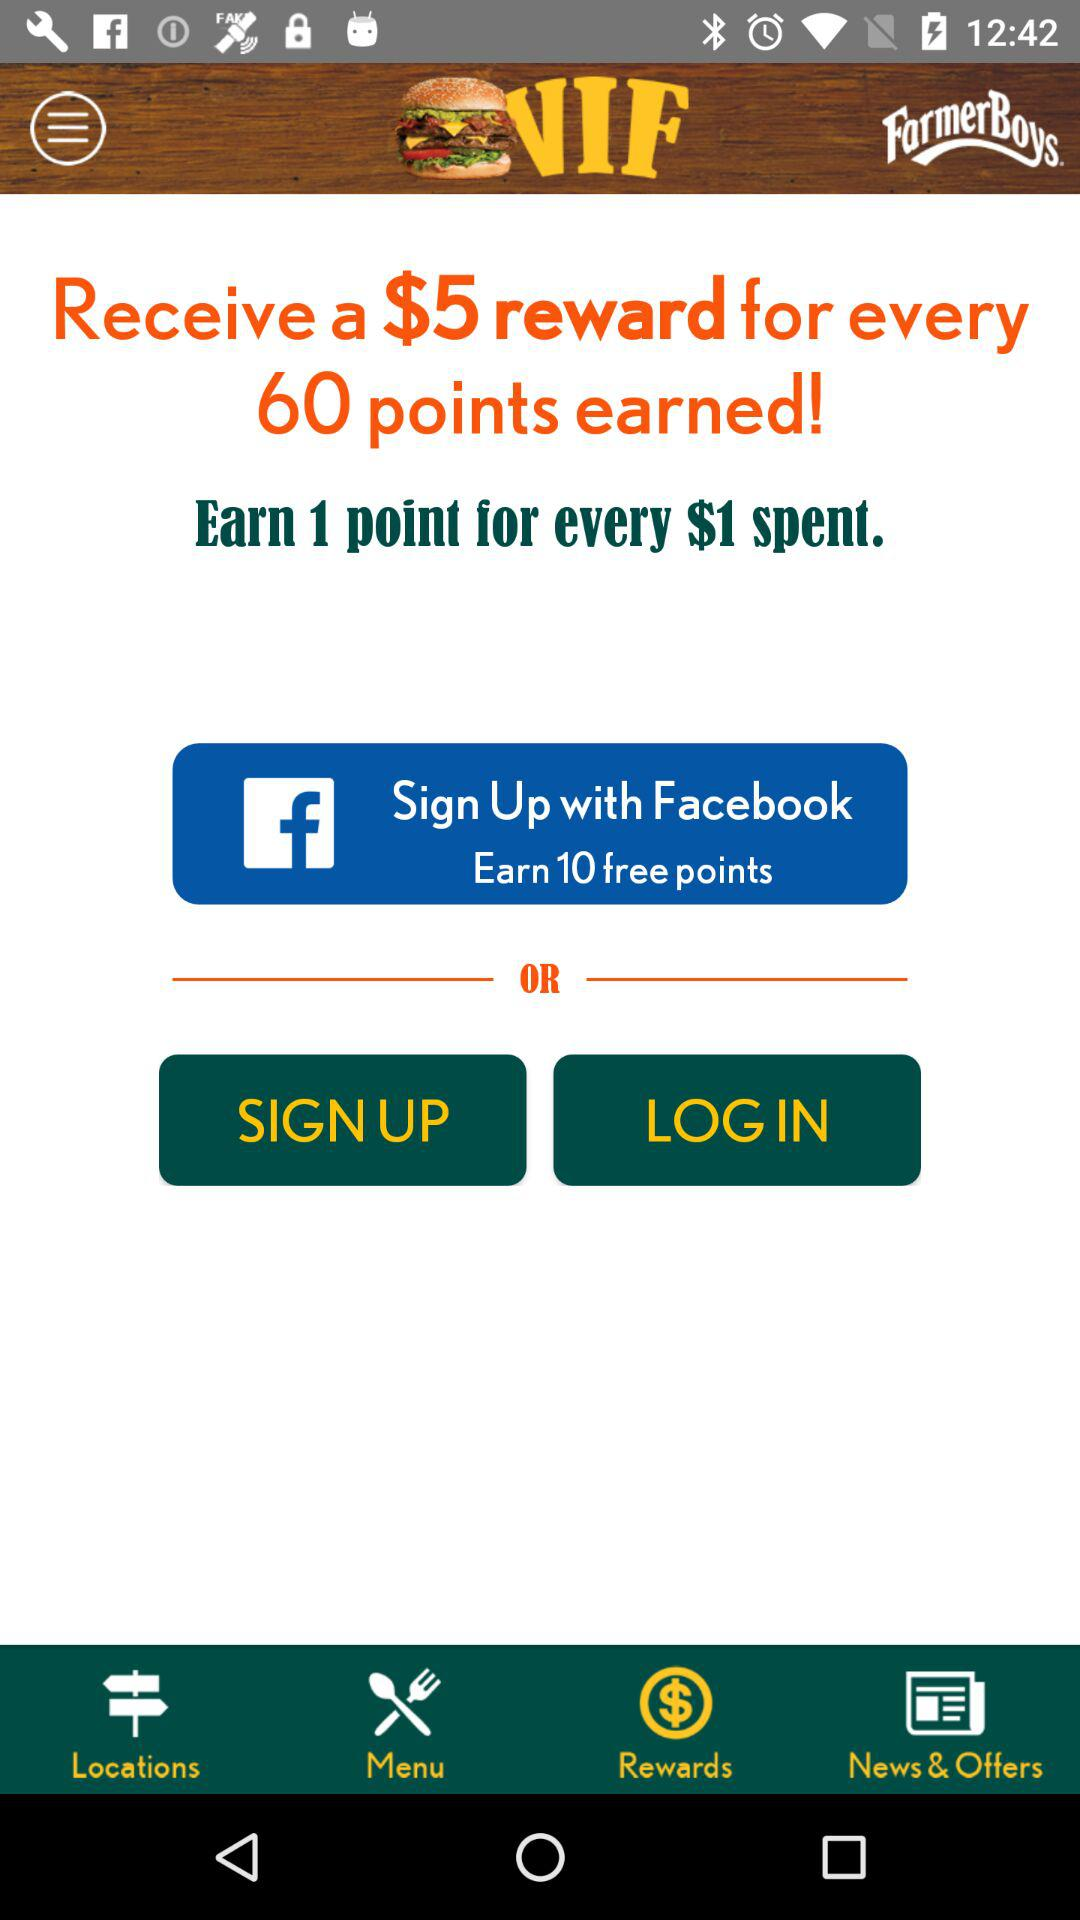What is the reward amount for every 60 points earned? The reward amount for every 60 points earned is $5. 